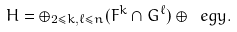Convert formula to latex. <formula><loc_0><loc_0><loc_500><loc_500>H = \oplus _ { 2 \leq k , \ell \leq n } ( F ^ { k } \cap G ^ { \ell } ) \oplus \ e g y .</formula> 